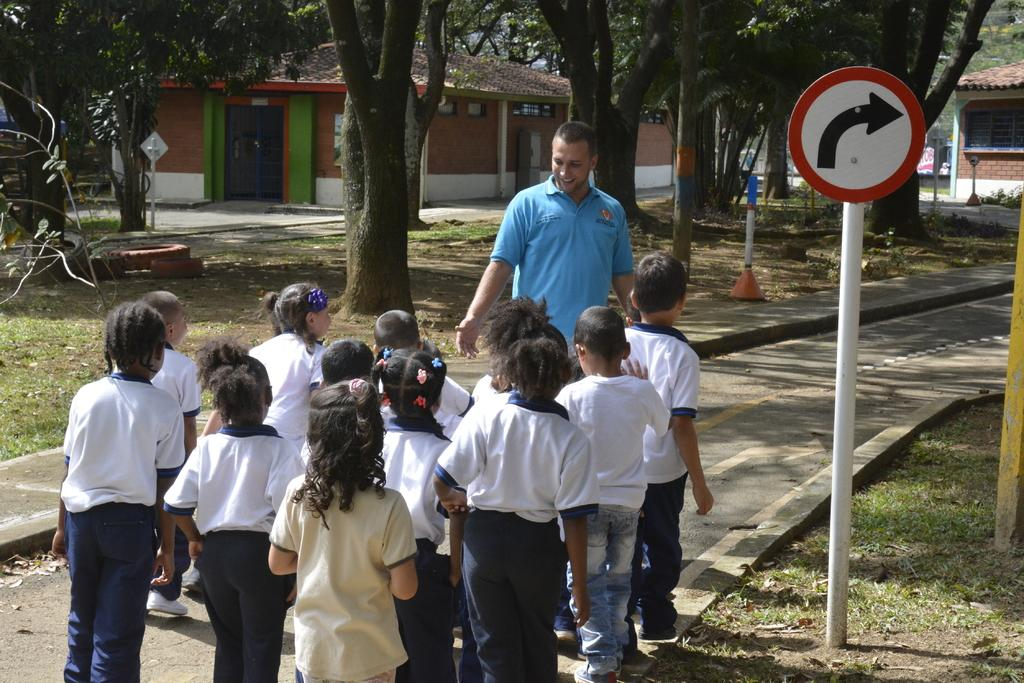Who is the main subject in the image? There is a man in the image. What is the relationship between the man and the children in front of him? The children are in front of the man, but their relationship is not specified in the image. What type of natural environment is visible in the image? There are trees and grass in the image. What type of structures can be seen in the image? There are houses in the image. What object is located on the right side of the image? There is a directional board on the right side of the image. What color of paint is being used by the parent in the image? There is no parent or paint present in the image. What is the hope of the children in the image? The image does not provide any information about the children's hopes or emotions. 